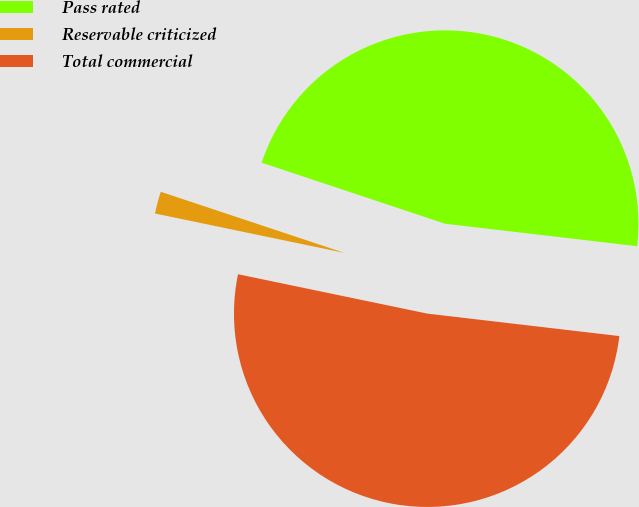Convert chart. <chart><loc_0><loc_0><loc_500><loc_500><pie_chart><fcel>Pass rated<fcel>Reservable criticized<fcel>Total commercial<nl><fcel>46.74%<fcel>1.85%<fcel>51.41%<nl></chart> 